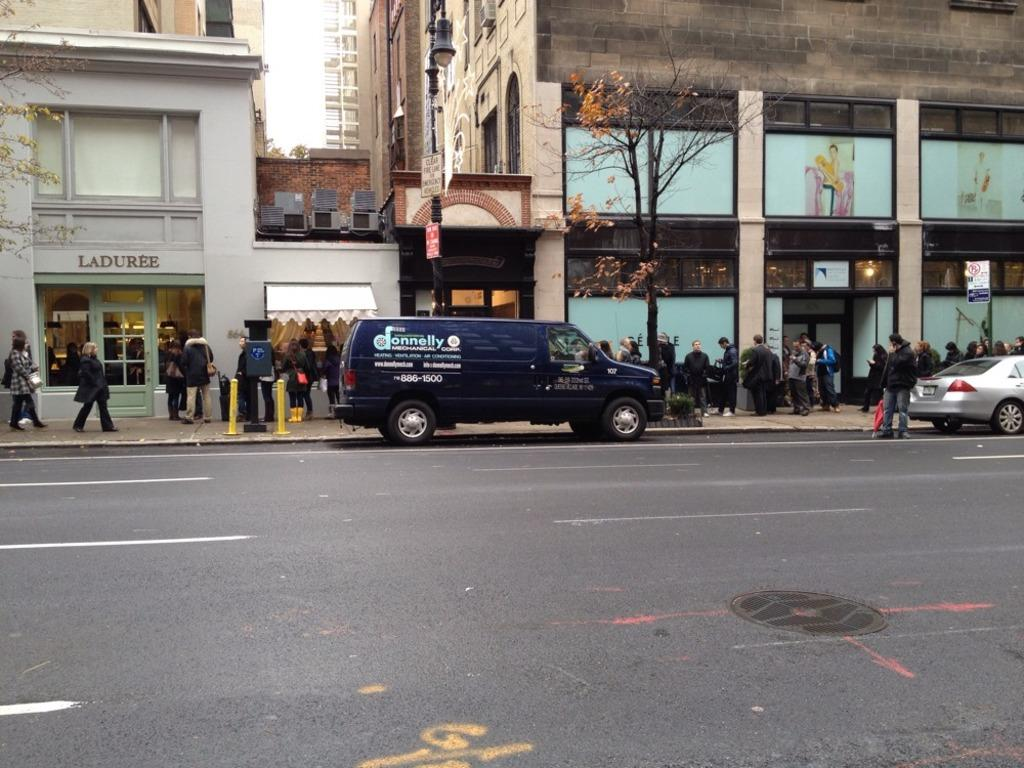<image>
Write a terse but informative summary of the picture. A van that says Donnelly on the side of it. 